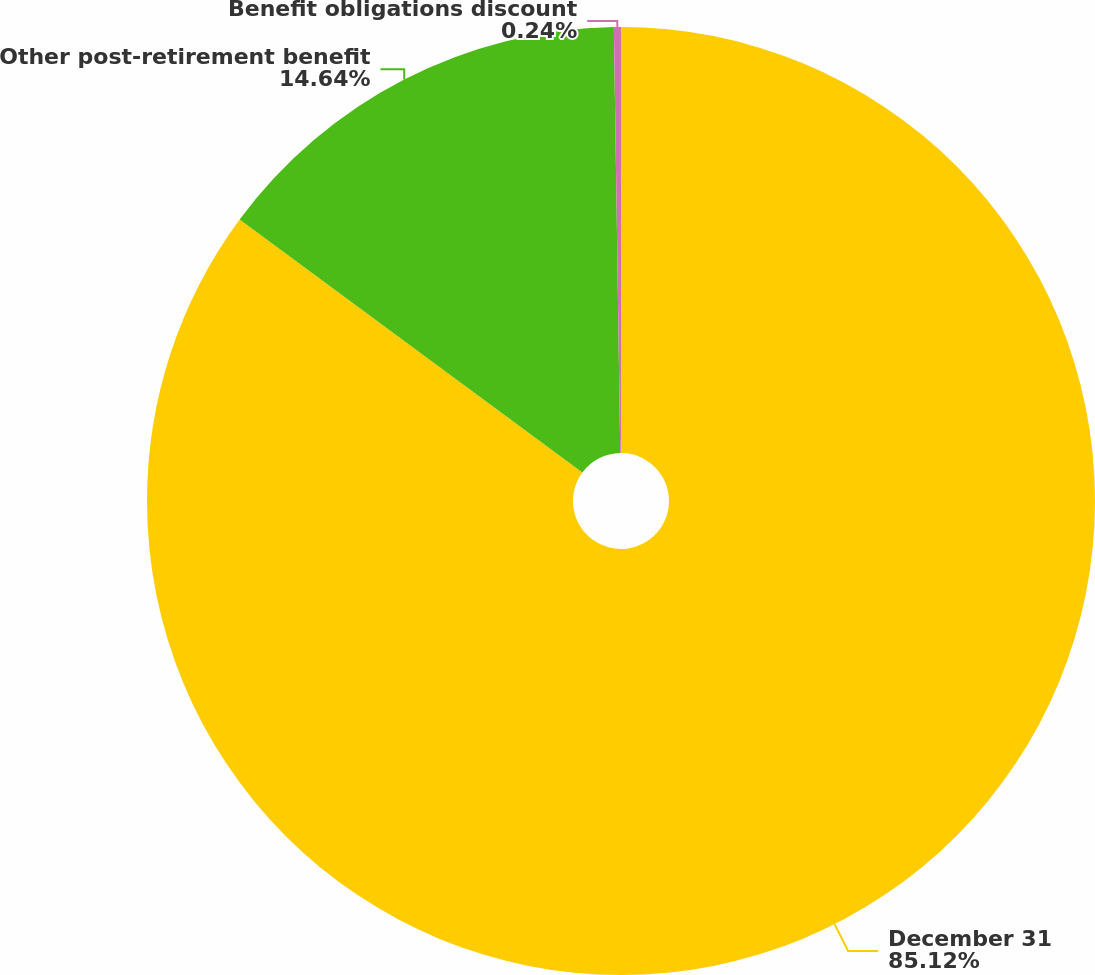Convert chart. <chart><loc_0><loc_0><loc_500><loc_500><pie_chart><fcel>December 31<fcel>Other post-retirement benefit<fcel>Benefit obligations discount<nl><fcel>85.12%<fcel>14.64%<fcel>0.24%<nl></chart> 